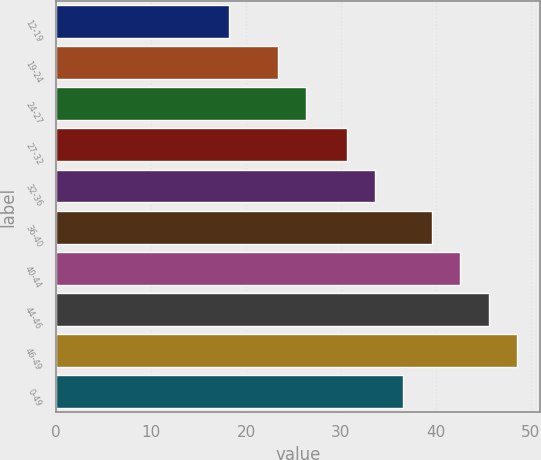Convert chart. <chart><loc_0><loc_0><loc_500><loc_500><bar_chart><fcel>12-19<fcel>19-24<fcel>24-27<fcel>27-32<fcel>32-36<fcel>36-40<fcel>40-44<fcel>44-46<fcel>46-49<fcel>0-49<nl><fcel>18.18<fcel>23.33<fcel>26.32<fcel>30.6<fcel>33.59<fcel>39.59<fcel>42.59<fcel>45.59<fcel>48.59<fcel>36.59<nl></chart> 